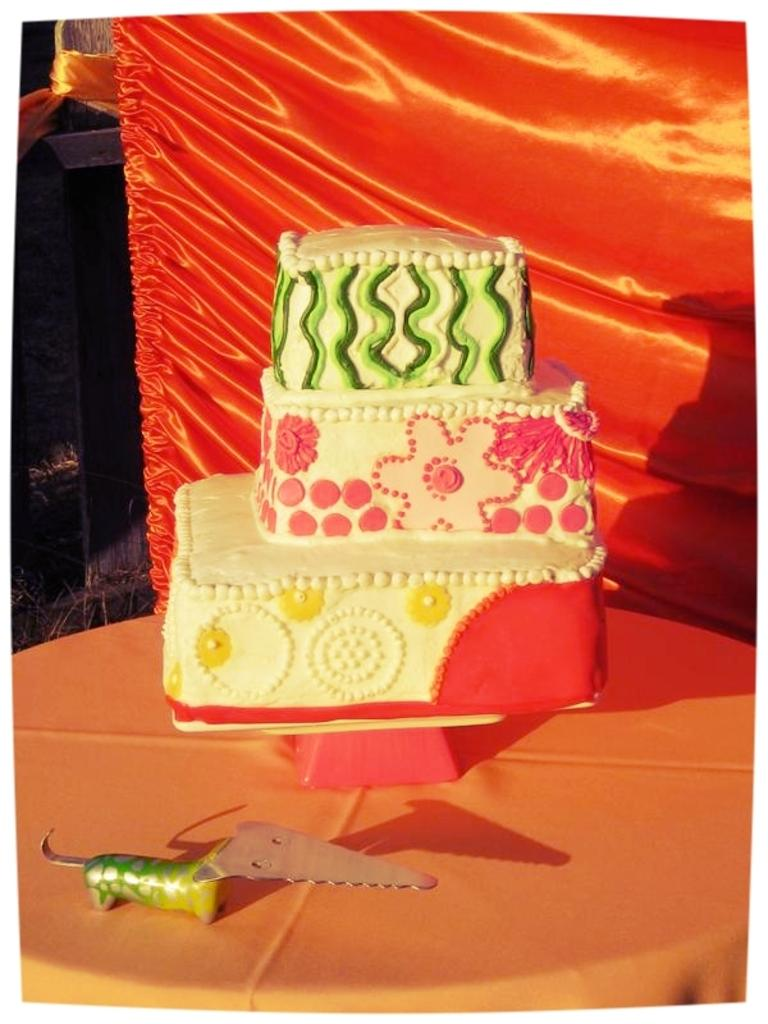What is the main subject of the image? There is a cake in the image. Where is the cake located? The cake is on an object. What else can be seen on the object with the cake? There is a knife on the object. What is visible behind the cake? There is a cloth visible behind the cake. What type of fruit is being cut with the celery in the image? There is no fruit or celery present in the image. How many additional objects are visible in the image besides the cake, object, knife, and cloth? There is no mention of a fifth object in the provided facts, so we cannot answer this question. 